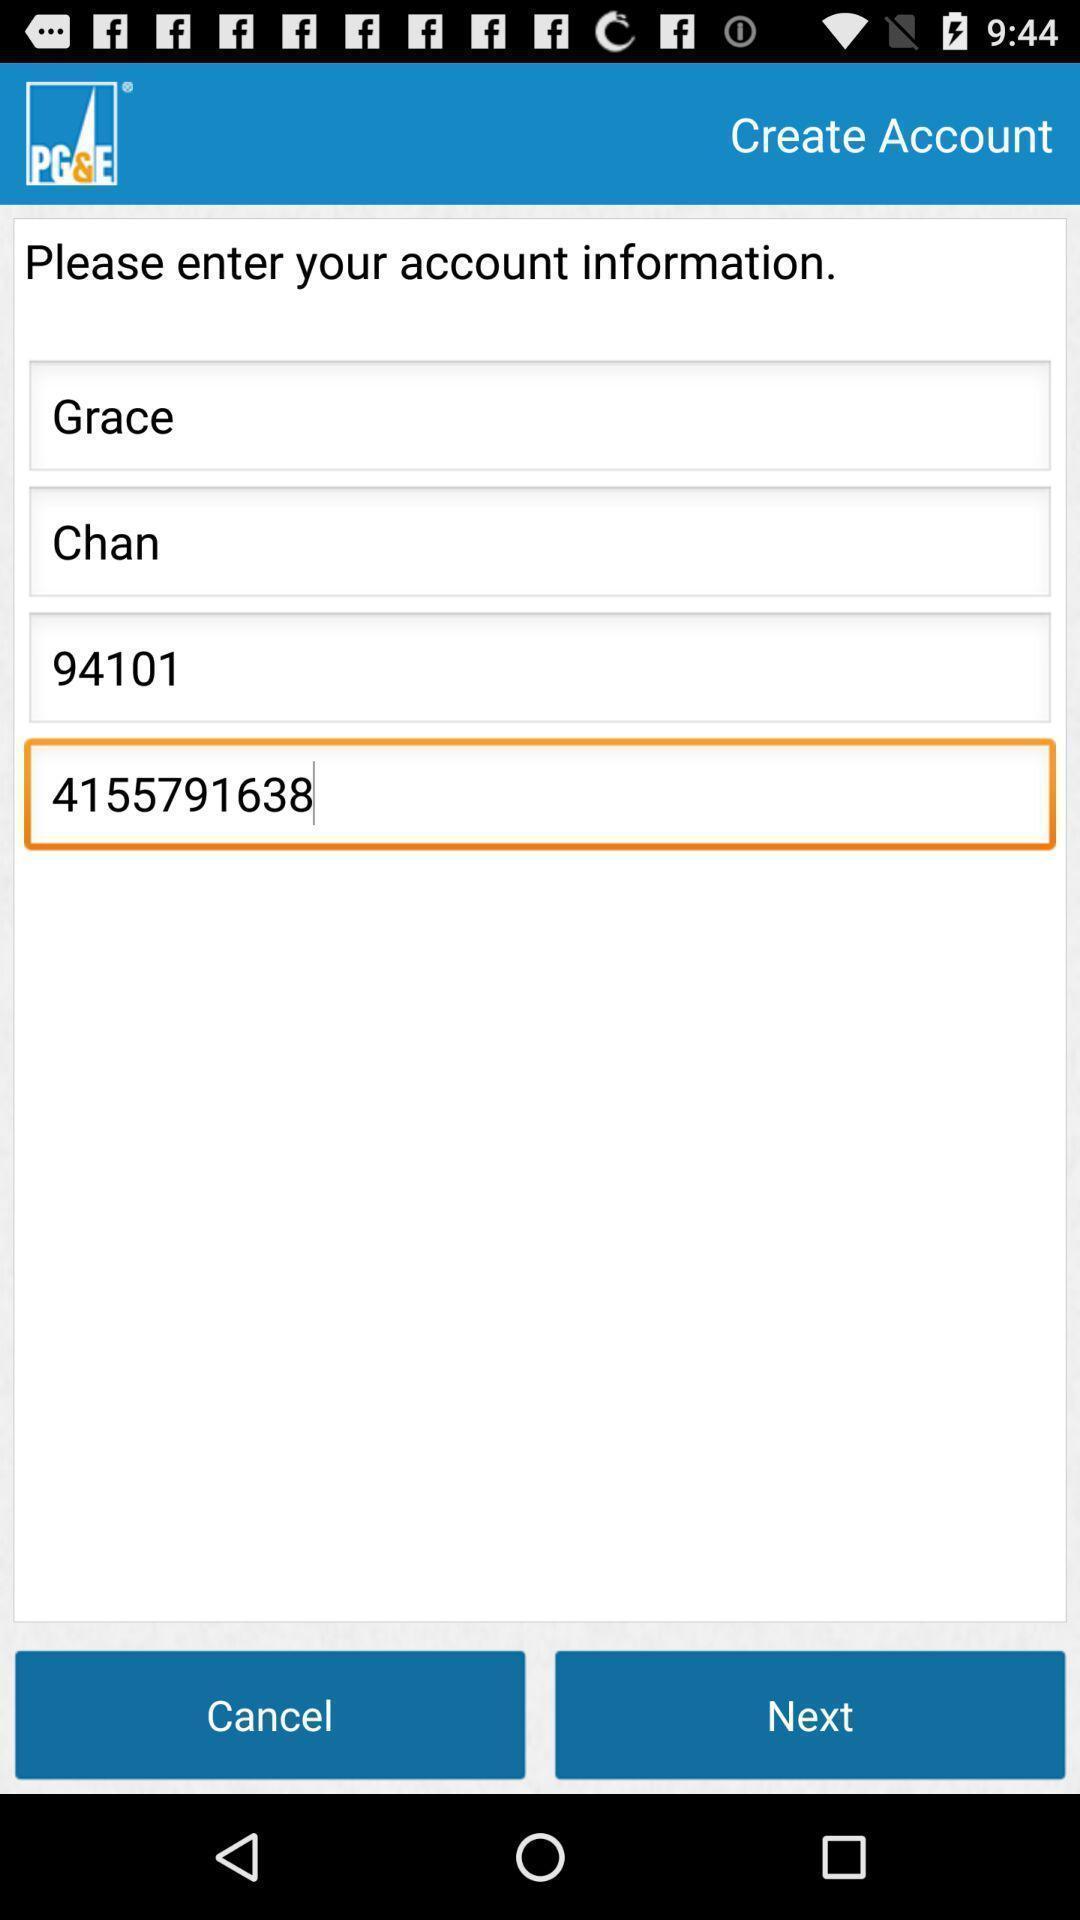Please provide a description for this image. Text boxes to enter the account information in application. 